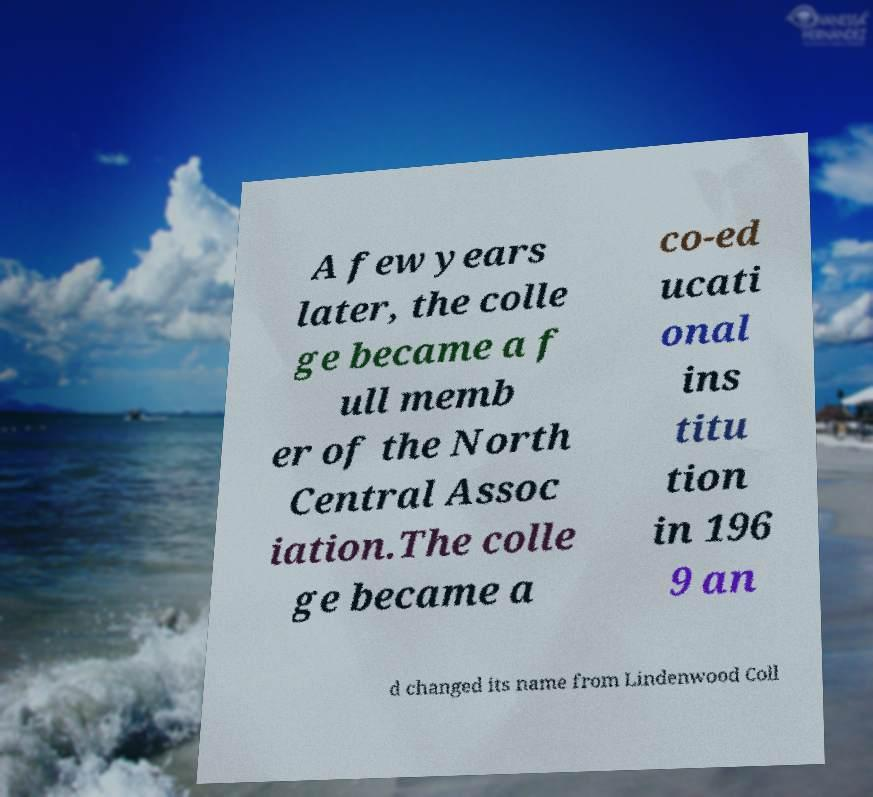I need the written content from this picture converted into text. Can you do that? A few years later, the colle ge became a f ull memb er of the North Central Assoc iation.The colle ge became a co-ed ucati onal ins titu tion in 196 9 an d changed its name from Lindenwood Coll 